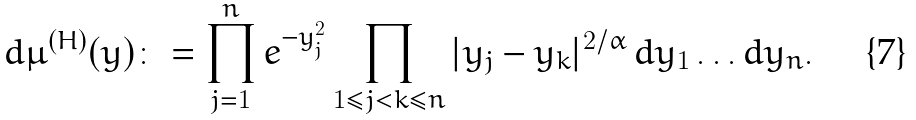Convert formula to latex. <formula><loc_0><loc_0><loc_500><loc_500>d \mu ^ { ( H ) } ( y ) \colon = \prod _ { j = 1 } ^ { n } e ^ { - y _ { j } ^ { 2 } } \prod _ { 1 \leq j < k \leq n } | y _ { j } - y _ { k } | ^ { 2 / \alpha } \, d y _ { 1 } \dots d y _ { n } .</formula> 